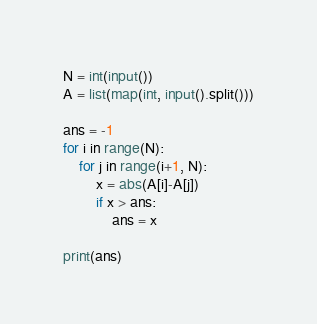<code> <loc_0><loc_0><loc_500><loc_500><_Python_>N = int(input())
A = list(map(int, input().split()))

ans = -1
for i in range(N):
    for j in range(i+1, N):
        x = abs(A[i]-A[j])
        if x > ans:
            ans = x

print(ans)

</code> 